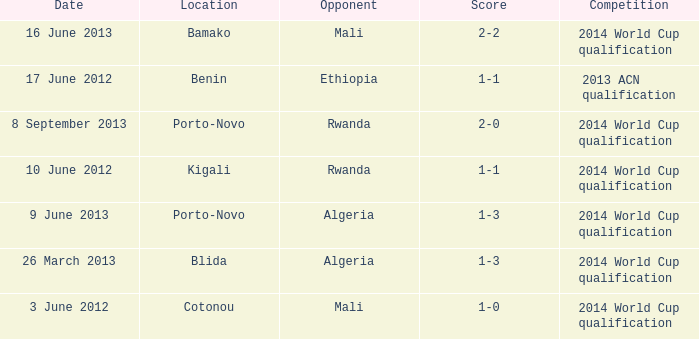What competition is located in bamako? 2014 World Cup qualification. 